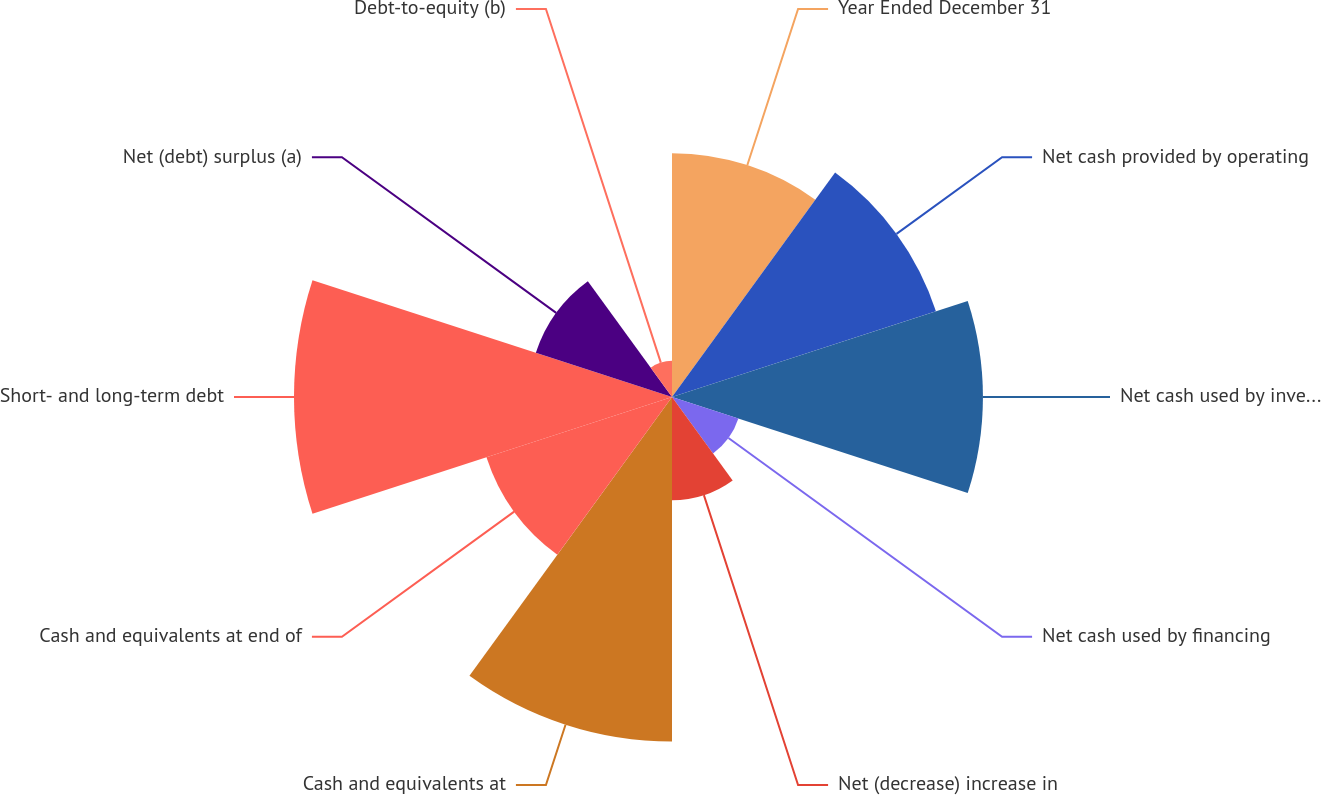Convert chart. <chart><loc_0><loc_0><loc_500><loc_500><pie_chart><fcel>Year Ended December 31<fcel>Net cash provided by operating<fcel>Net cash used by investing<fcel>Net cash used by financing<fcel>Net (decrease) increase in<fcel>Cash and equivalents at<fcel>Cash and equivalents at end of<fcel>Short- and long-term debt<fcel>Net (debt) surplus (a)<fcel>Debt-to-equity (b)<nl><fcel>11.6%<fcel>13.2%<fcel>14.79%<fcel>3.32%<fcel>4.91%<fcel>16.39%<fcel>9.28%<fcel>17.98%<fcel>6.81%<fcel>1.72%<nl></chart> 